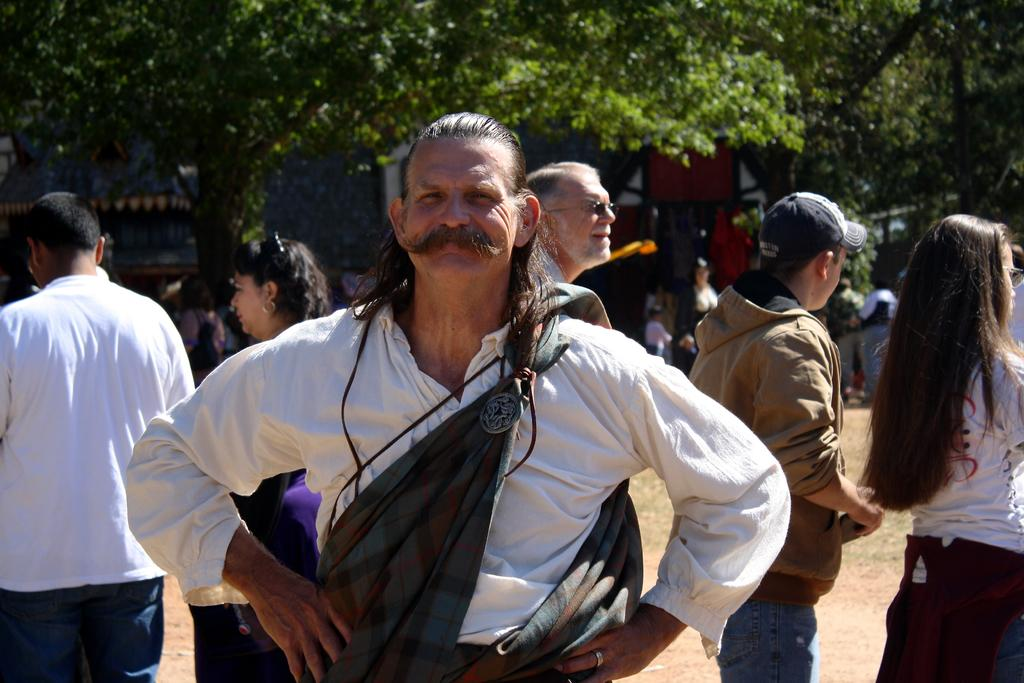What is the main subject of the image? There is a person in the image. Are there any other people visible in the image? Yes, there are other people standing behind the person. What can be seen in the distance in the image? There are buildings and trees in the background of the image. What type of jelly is being served at the person's birthday party in the image? There is no indication of a birthday party or jelly in the image. Can you see any feathers on the person's hat in the image? There is no hat or feathers visible in the image. 